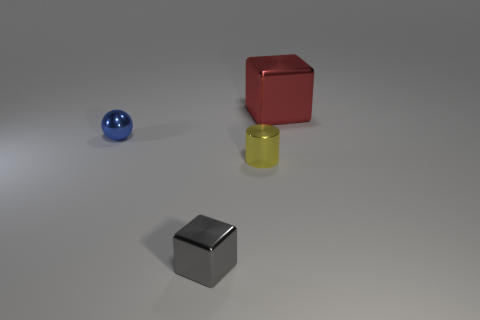How many other things are made of the same material as the tiny sphere?
Your answer should be very brief. 3. How many blue things are either small metal spheres or small cylinders?
Your answer should be very brief. 1. Are there an equal number of large shiny objects to the left of the large red shiny thing and red metal cubes?
Your answer should be compact. No. Is there any other thing that has the same size as the cylinder?
Give a very brief answer. Yes. What is the color of the other tiny thing that is the same shape as the red thing?
Your answer should be compact. Gray. What number of other metallic objects have the same shape as the red object?
Provide a succinct answer. 1. How many gray metallic blocks are there?
Provide a short and direct response. 1. Is there a tiny blue object that has the same material as the small cube?
Provide a succinct answer. Yes. There is a thing to the left of the gray metal thing; is it the same size as the metal object that is in front of the yellow cylinder?
Keep it short and to the point. Yes. There is a object behind the small blue metallic ball; what is its size?
Keep it short and to the point. Large. 